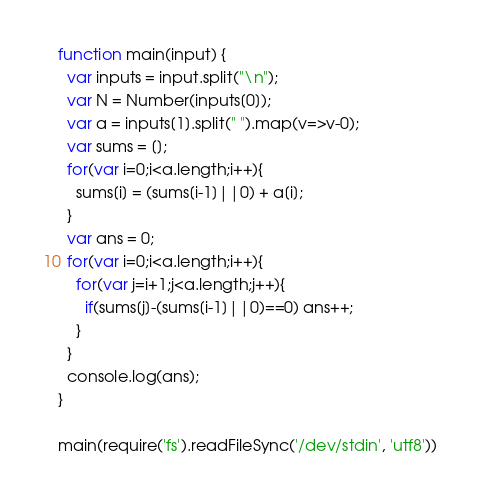Convert code to text. <code><loc_0><loc_0><loc_500><loc_500><_JavaScript_>function main(input) {
  var inputs = input.split("\n");
  var N = Number(inputs[0]);
  var a = inputs[1].split(" ").map(v=>v-0);
  var sums = [];
  for(var i=0;i<a.length;i++){
    sums[i] = (sums[i-1]||0) + a[i];
  }
  var ans = 0;
  for(var i=0;i<a.length;i++){
    for(var j=i+1;j<a.length;j++){
      if(sums[j]-(sums[i-1]||0)==0) ans++;
    }
  }
  console.log(ans);
}

main(require('fs').readFileSync('/dev/stdin', 'utf8'))
</code> 